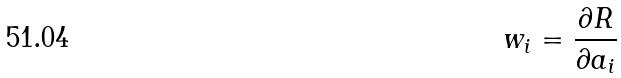<formula> <loc_0><loc_0><loc_500><loc_500>w _ { i } = \frac { \partial R } { \partial a _ { i } }</formula> 